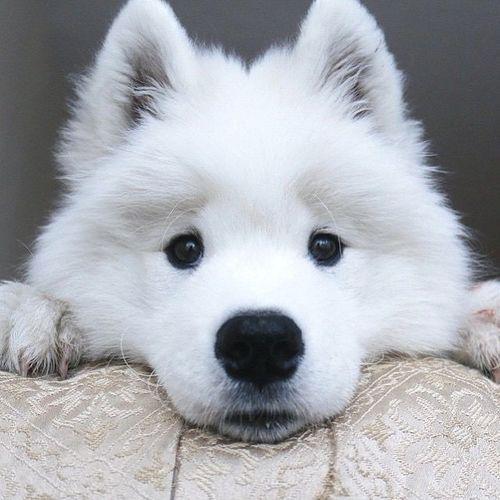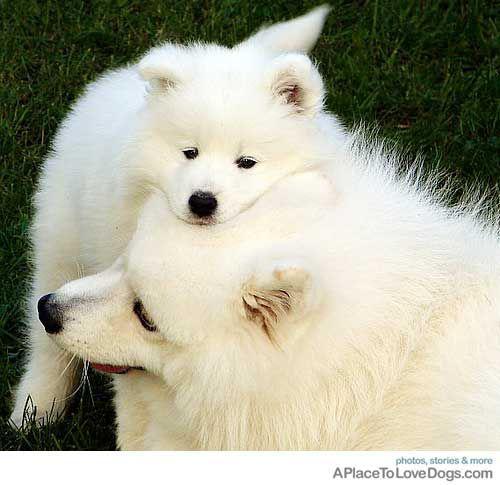The first image is the image on the left, the second image is the image on the right. For the images displayed, is the sentence "There are exactly three dogs." factually correct? Answer yes or no. Yes. 